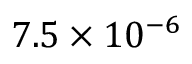Convert formula to latex. <formula><loc_0><loc_0><loc_500><loc_500>7 . 5 \times 1 0 ^ { - 6 }</formula> 